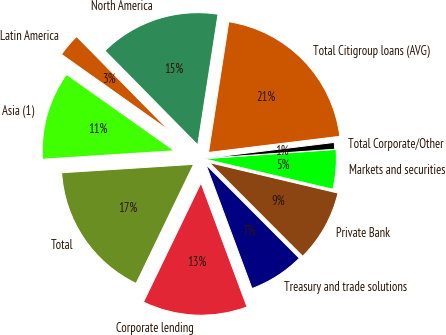Convert chart. <chart><loc_0><loc_0><loc_500><loc_500><pie_chart><fcel>North America<fcel>Latin America<fcel>Asia (1)<fcel>Total<fcel>Corporate lending<fcel>Treasury and trade solutions<fcel>Private Bank<fcel>Markets and securities<fcel>Total Corporate/Other<fcel>Total Citigroup loans (AVG)<nl><fcel>14.82%<fcel>2.82%<fcel>10.82%<fcel>16.82%<fcel>12.82%<fcel>6.82%<fcel>8.82%<fcel>4.82%<fcel>0.82%<fcel>20.6%<nl></chart> 